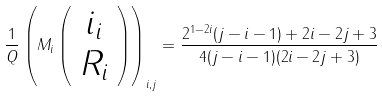<formula> <loc_0><loc_0><loc_500><loc_500>\frac { 1 } { Q } \left ( M _ { i } \left ( \begin{array} { c } i _ { i } \\ R _ { i } \\ \end{array} \right ) \right ) _ { i , j } = \frac { 2 ^ { 1 - 2 i } ( j - i - 1 ) + 2 i - 2 j + 3 } { 4 ( j - i - 1 ) ( 2 i - 2 j + 3 ) }</formula> 